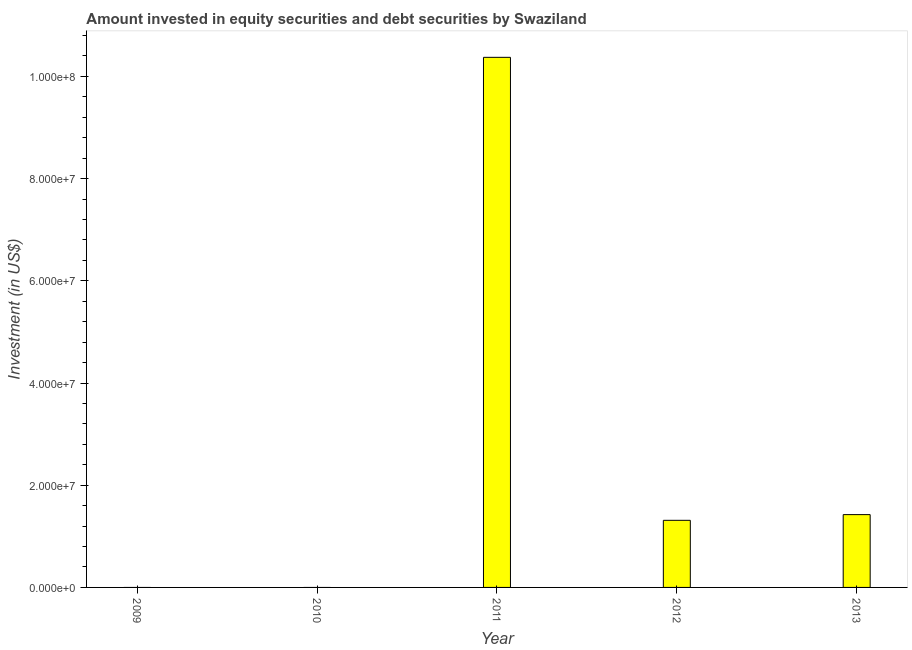Does the graph contain grids?
Make the answer very short. No. What is the title of the graph?
Offer a very short reply. Amount invested in equity securities and debt securities by Swaziland. What is the label or title of the Y-axis?
Offer a terse response. Investment (in US$). Across all years, what is the maximum portfolio investment?
Make the answer very short. 1.04e+08. Across all years, what is the minimum portfolio investment?
Provide a succinct answer. 0. What is the sum of the portfolio investment?
Provide a short and direct response. 1.31e+08. What is the difference between the portfolio investment in 2011 and 2013?
Keep it short and to the point. 8.95e+07. What is the average portfolio investment per year?
Your answer should be compact. 2.62e+07. What is the median portfolio investment?
Make the answer very short. 1.31e+07. What is the ratio of the portfolio investment in 2011 to that in 2012?
Provide a succinct answer. 7.9. What is the difference between the highest and the second highest portfolio investment?
Give a very brief answer. 8.95e+07. Is the sum of the portfolio investment in 2012 and 2013 greater than the maximum portfolio investment across all years?
Ensure brevity in your answer.  No. What is the difference between the highest and the lowest portfolio investment?
Provide a short and direct response. 1.04e+08. How many bars are there?
Offer a very short reply. 3. Are all the bars in the graph horizontal?
Offer a terse response. No. What is the difference between two consecutive major ticks on the Y-axis?
Ensure brevity in your answer.  2.00e+07. Are the values on the major ticks of Y-axis written in scientific E-notation?
Your response must be concise. Yes. What is the Investment (in US$) of 2011?
Your answer should be compact. 1.04e+08. What is the Investment (in US$) of 2012?
Your answer should be compact. 1.31e+07. What is the Investment (in US$) of 2013?
Keep it short and to the point. 1.42e+07. What is the difference between the Investment (in US$) in 2011 and 2012?
Your answer should be very brief. 9.06e+07. What is the difference between the Investment (in US$) in 2011 and 2013?
Provide a short and direct response. 8.95e+07. What is the difference between the Investment (in US$) in 2012 and 2013?
Make the answer very short. -1.12e+06. What is the ratio of the Investment (in US$) in 2011 to that in 2012?
Provide a succinct answer. 7.9. What is the ratio of the Investment (in US$) in 2011 to that in 2013?
Keep it short and to the point. 7.28. What is the ratio of the Investment (in US$) in 2012 to that in 2013?
Provide a short and direct response. 0.92. 